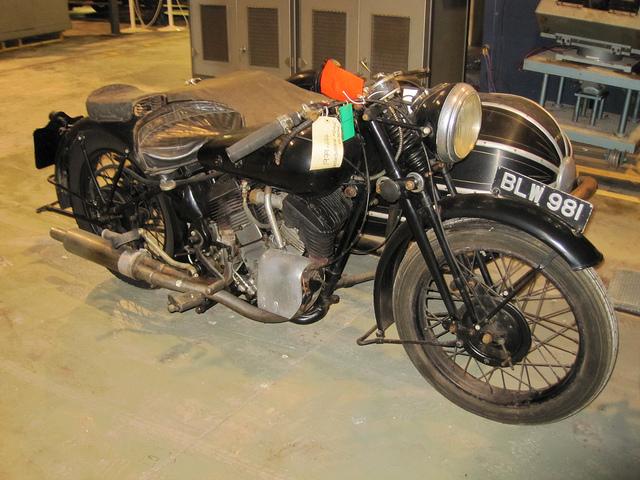How many motorcycles are there?
Concise answer only. 1. How many lights are on the front of this motorcycle?
Write a very short answer. 1. What color is the bike?
Give a very brief answer. Black. Is there a blue tag on the bike?
Quick response, please. No. What number is on the bike?
Keep it brief. 981. What are the letters in white?
Concise answer only. Blw. What are the letters on the license plate?
Answer briefly. Blw. What is the license plate of the third motorcycle to the right?
Answer briefly. Blw 981. 